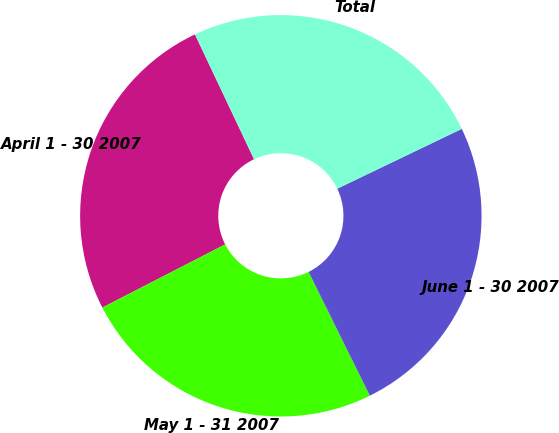<chart> <loc_0><loc_0><loc_500><loc_500><pie_chart><fcel>April 1 - 30 2007<fcel>May 1 - 31 2007<fcel>June 1 - 30 2007<fcel>Total<nl><fcel>25.52%<fcel>24.75%<fcel>24.82%<fcel>24.91%<nl></chart> 